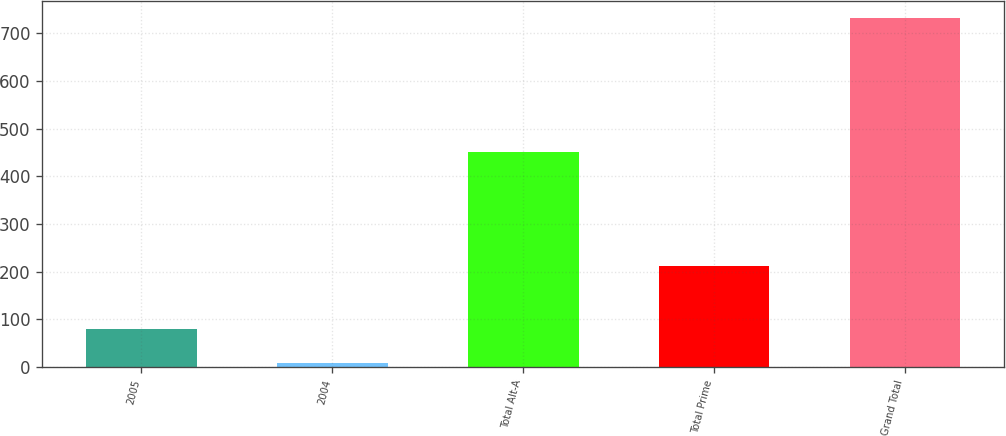Convert chart. <chart><loc_0><loc_0><loc_500><loc_500><bar_chart><fcel>2005<fcel>2004<fcel>Total Alt-A<fcel>Total Prime<fcel>Grand Total<nl><fcel>80.3<fcel>8<fcel>450<fcel>213<fcel>731<nl></chart> 